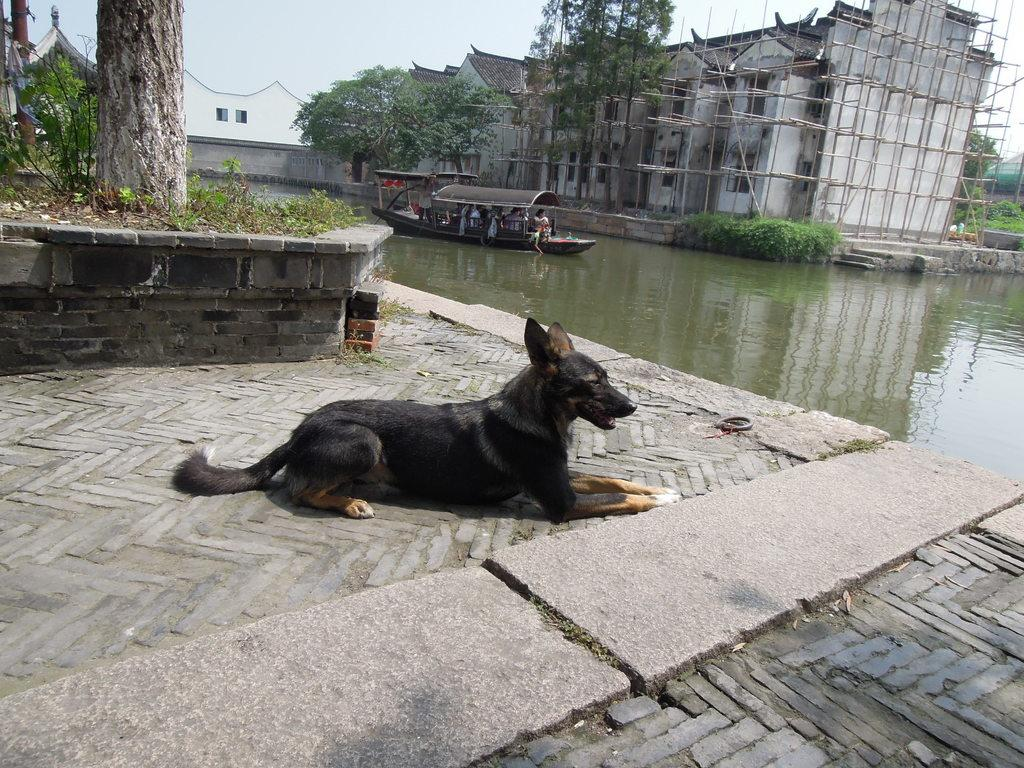What animal is sitting on the ground in the image? There is a dog sitting on the ground in the image. What is happening on the water in the image? There is a boat with people on the water in the image. What can be seen in the background of the image? There is a building, plants, and trees visible in the background of the image. What type of cheese is being advertised on the sign in the image? There is no sign present in the image, so it is not possible to determine if any cheese is being advertised. What is the cause of the war depicted in the image? There is no war depicted in the image; it features a dog sitting on the ground, a boat with people on the water, and a background with a building, plants, and trees. 